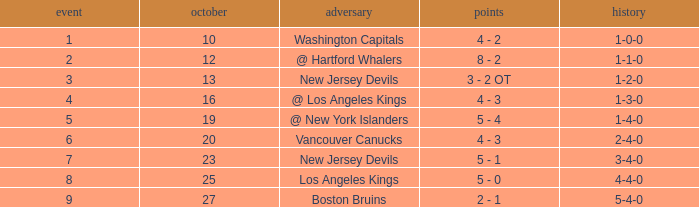What was the average game with a record of 4-4-0? 8.0. 